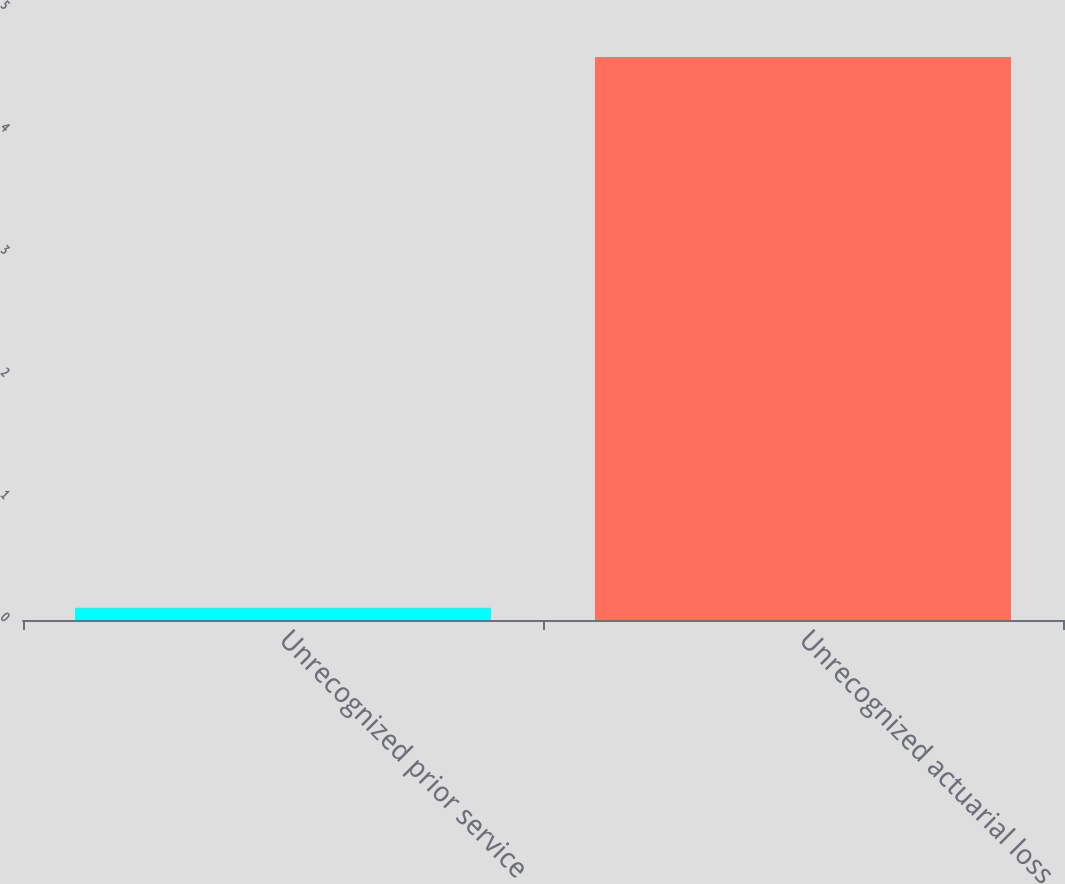<chart> <loc_0><loc_0><loc_500><loc_500><bar_chart><fcel>Unrecognized prior service<fcel>Unrecognized actuarial loss<nl><fcel>0.1<fcel>4.6<nl></chart> 